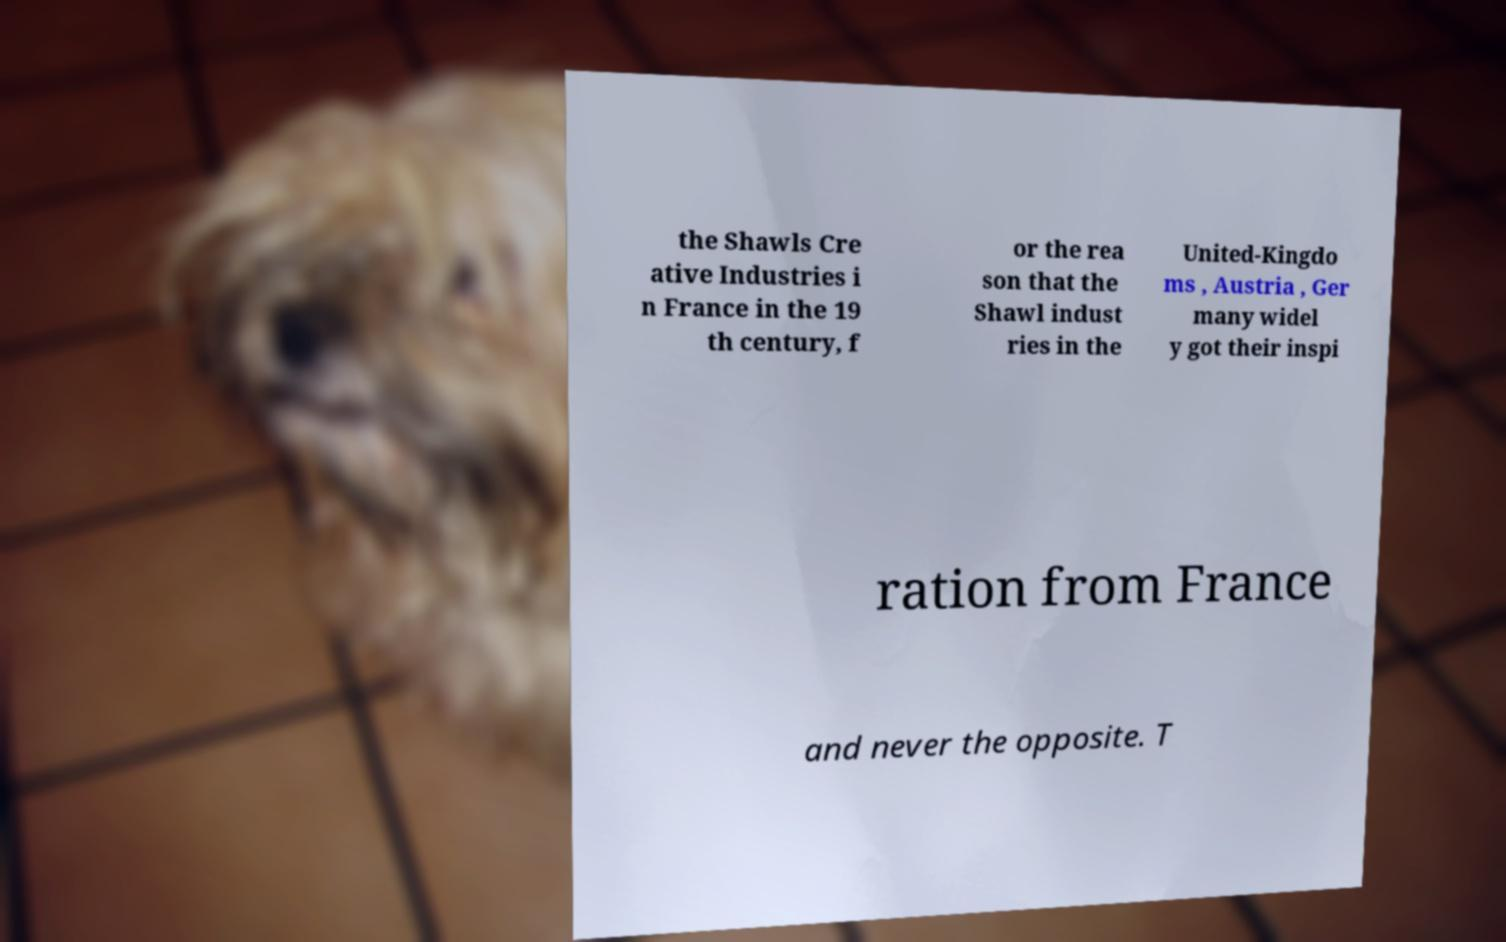What messages or text are displayed in this image? I need them in a readable, typed format. the Shawls Cre ative Industries i n France in the 19 th century, f or the rea son that the Shawl indust ries in the United-Kingdo ms , Austria , Ger many widel y got their inspi ration from France and never the opposite. T 